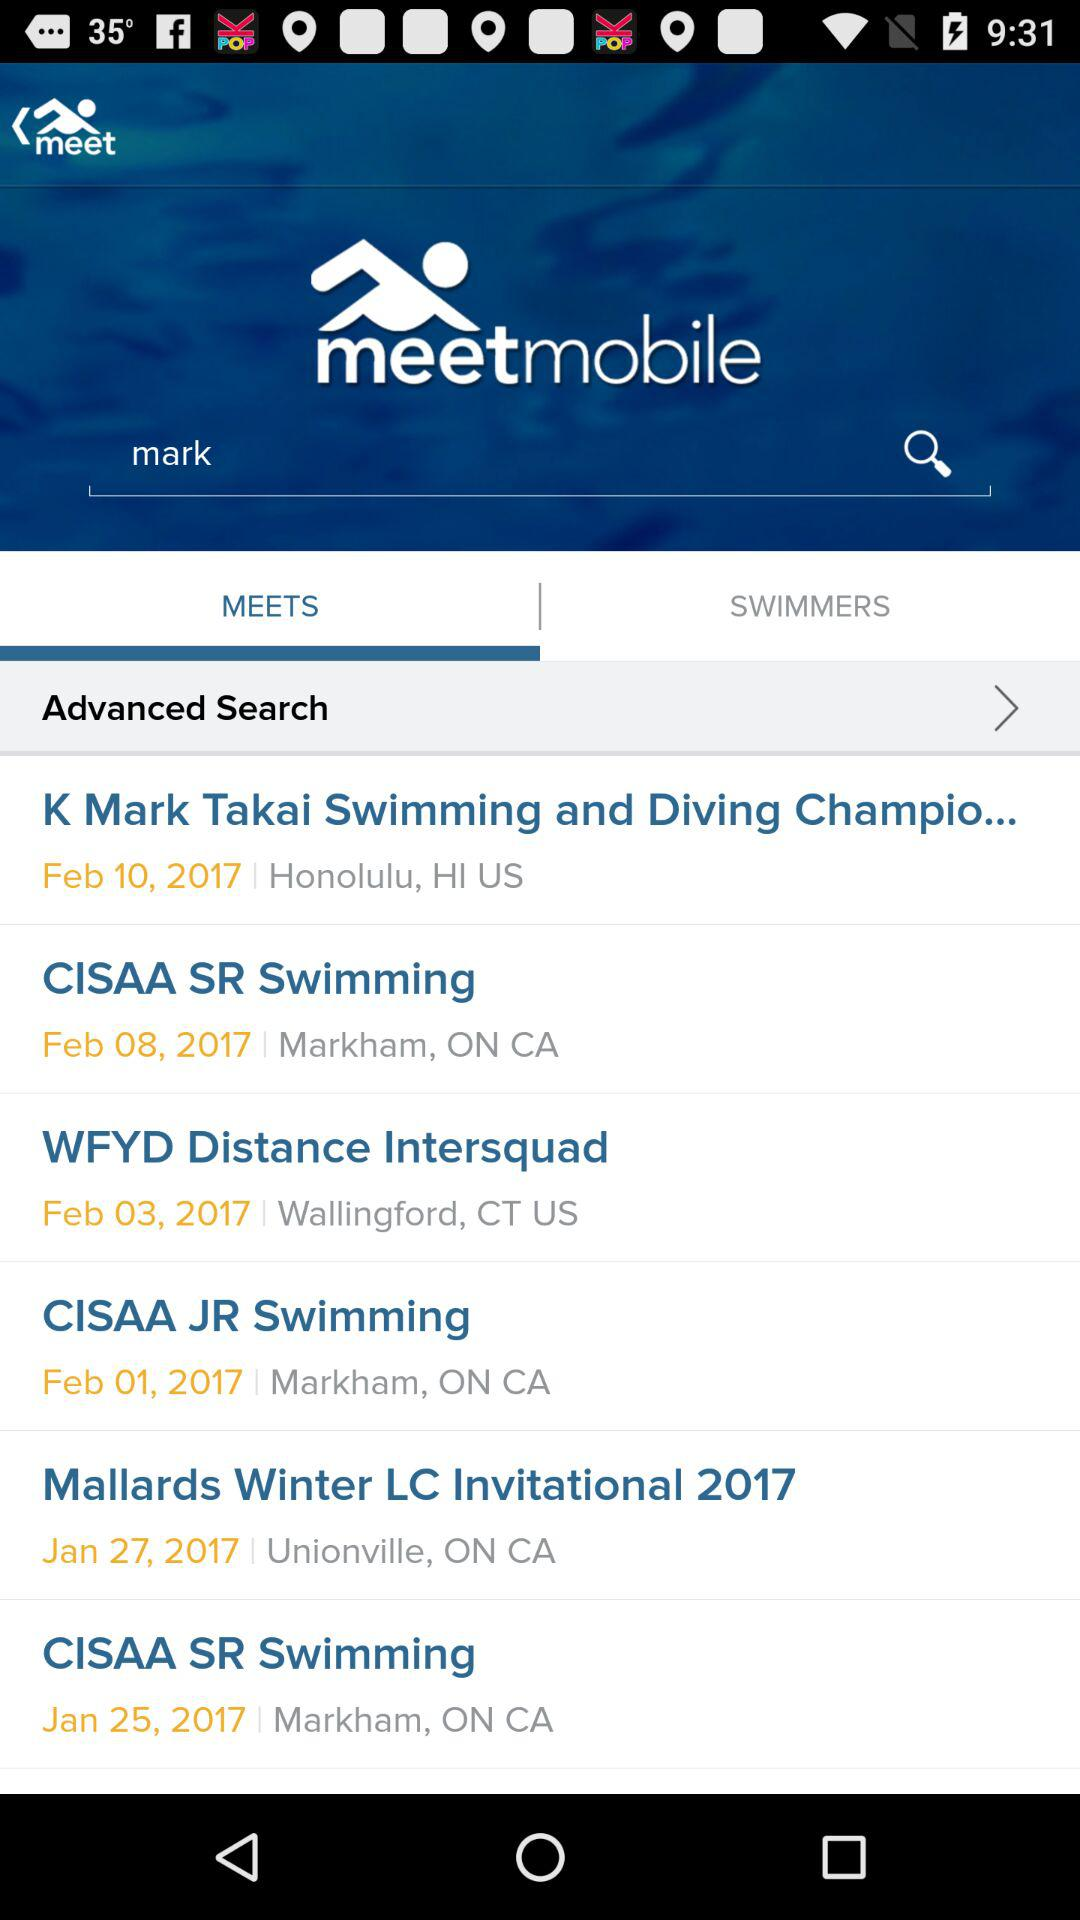What is the name of the application? The name of the application is "meetmobile". 